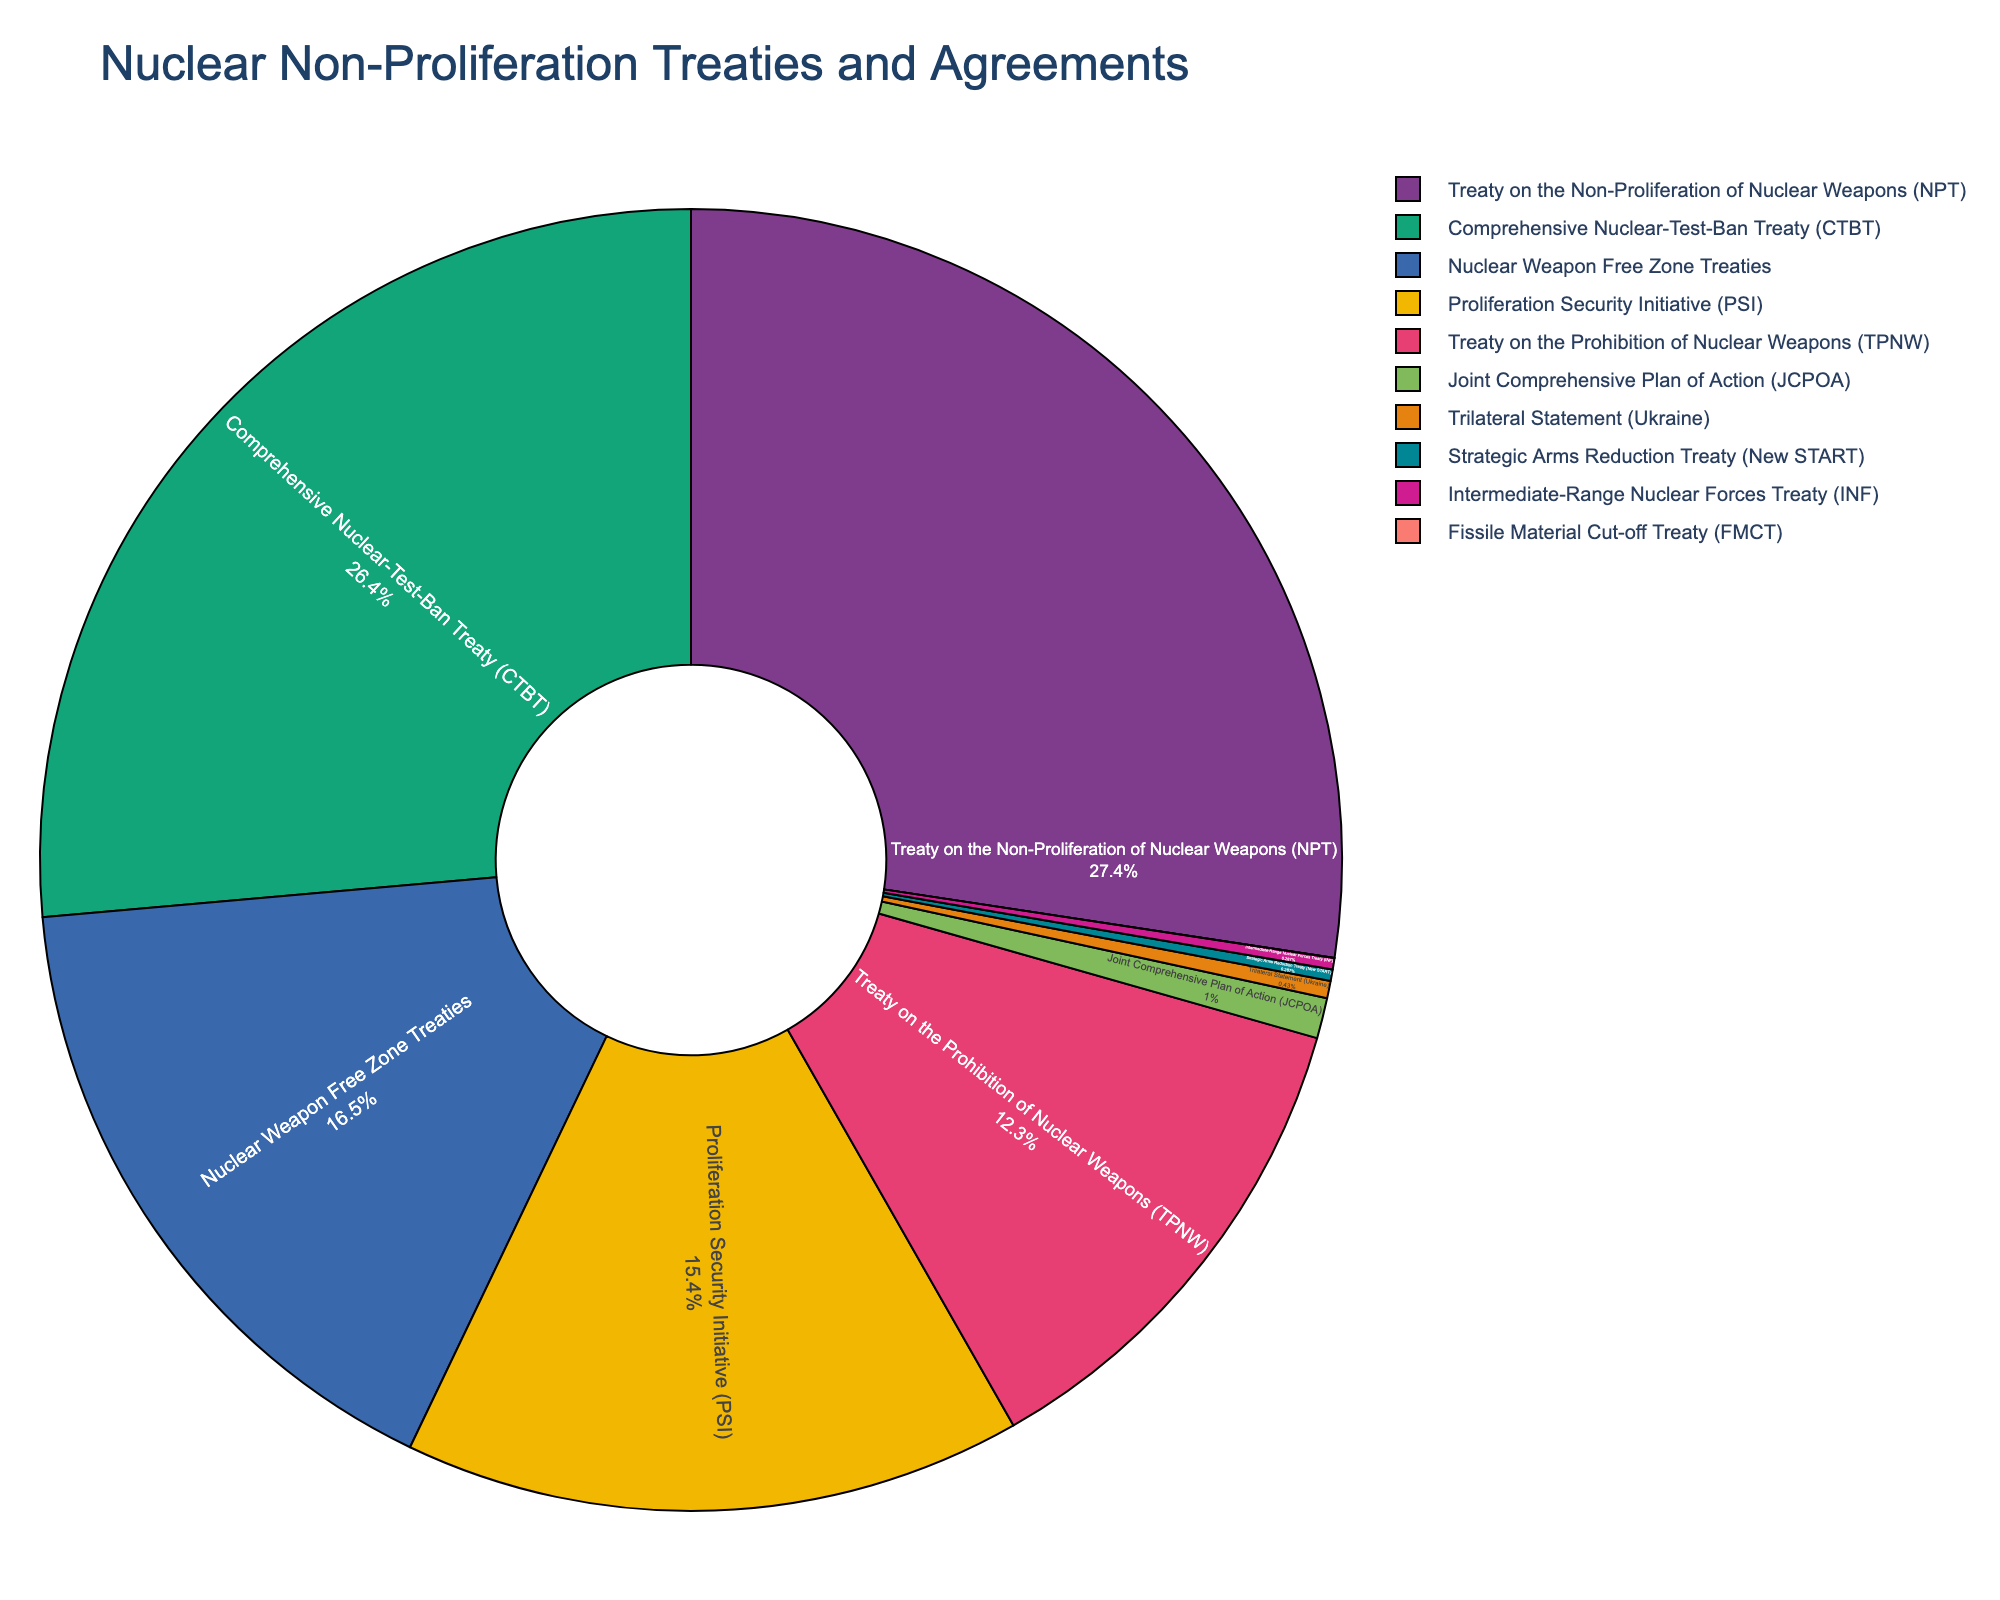What's the largest treaty in terms of the number of signatories? The largest treaty by signatories can be identified by examining the pie chart segment with the largest percentage. The Treaty on the Non-Proliferation of Nuclear Weapons (NPT) occupies the largest segment.
Answer: Treaty on the Non-Proliferation of Nuclear Weapons (NPT) How many treaties have less than 10 signatories each? Examine the segments with the smallest percentages in the pie chart. The Fissile Material Cut-off Treaty (FMCT) (0), Strategic Arms Reduction Treaty (New START) (2), Intermediate-Range Nuclear Forces Treaty (INF) (2), and Trilateral Statement (Ukraine) (3) each have less than 10 signatories.
Answer: 4 treaties Which two treaties have the same number of signatories? Look for segments with equal sizes in the pie chart. The Strategic Arms Reduction Treaty (New START) and Intermediate-Range Nuclear Forces Treaty (INF) both have 2 signatories each.
Answer: Strategic Arms Reduction Treaty (New START) and Intermediate-Range Nuclear Forces Treaty (INF) What is the total number of signatories for the Nuclear Weapon Free Zone Treaties and the Treaty on the Prohibition of Nuclear Weapons combined? Add the number of signatories for both treaties: 115 (Nuclear Weapon Free Zone Treaties) + 86 (Treaty on the Prohibition of Nuclear Weapons).
Answer: 201 By how much does the number of signatories for the Proliferation Security Initiative (PSI) exceed that of the Joint Comprehensive Plan of Action (JCPOA)? Subtract the number of signatories of JCPOA from that of PSI: 107 (PSI) - 7 (JCPOA).
Answer: 100 How does the number of signatories for the Comprehensive Nuclear-Test-Ban Treaty (CTBT) compare to the Nuclear Weapon Free Zone Treaties? Compare the values from the pie chart, noting that CTBT has 184 signatories, while Nuclear Weapon Free Zone Treaties have 115 signatories. Thus, the CTBT has more signatories.
Answer: CTBT has more signatories What percentage of the total signatories does the Treaty on the Non-Proliferation of Nuclear Weapons (NPT) represent approximately? Calculate the approximate percentage by dividing the number of signatories for the NPT by the total number of signatories in the chart, and then converting to a percentage: 191 / (Total Signatories) * 100. Without exact total, observe from the pie chart that it is the largest segment, approximately 30-40%.
Answer: Approximately 30-40% Which treaty/agreement has the smallest representation in the pie chart? The pie chart segment with the smallest size represents the Fissile Material Cut-off Treaty (FMCT), which has 0 signatories.
Answer: Fissile Material Cut-off Treaty (FMCT) What is the combined number of signatories for the Treaty on the Non-Proliferation of Nuclear Weapons (NPT) and Comprehensive Nuclear-Test-Ban Treaty (CTBT)? Add the number of signatories for both treaties: 191 (NPT) + 184 (CTBT).
Answer: 375 Can you identify which treaty/agreement has a number of signatories closest to 100? Examine the pie chart and look for the segment with a value nearest to 100. The Proliferation Security Initiative (PSI) has 107 signatories, which is closest to 100.
Answer: Proliferation Security Initiative (PSI) 